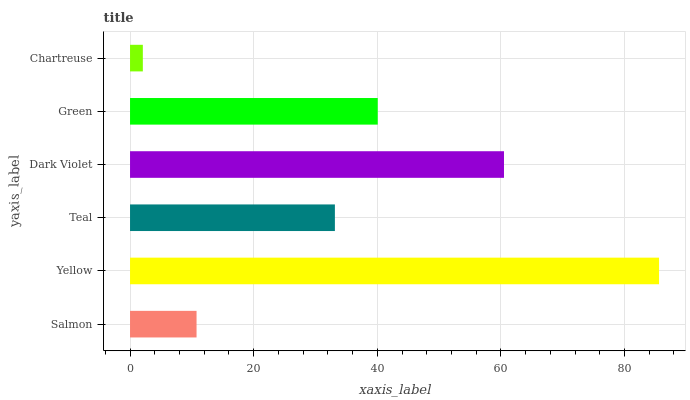Is Chartreuse the minimum?
Answer yes or no. Yes. Is Yellow the maximum?
Answer yes or no. Yes. Is Teal the minimum?
Answer yes or no. No. Is Teal the maximum?
Answer yes or no. No. Is Yellow greater than Teal?
Answer yes or no. Yes. Is Teal less than Yellow?
Answer yes or no. Yes. Is Teal greater than Yellow?
Answer yes or no. No. Is Yellow less than Teal?
Answer yes or no. No. Is Green the high median?
Answer yes or no. Yes. Is Teal the low median?
Answer yes or no. Yes. Is Chartreuse the high median?
Answer yes or no. No. Is Green the low median?
Answer yes or no. No. 